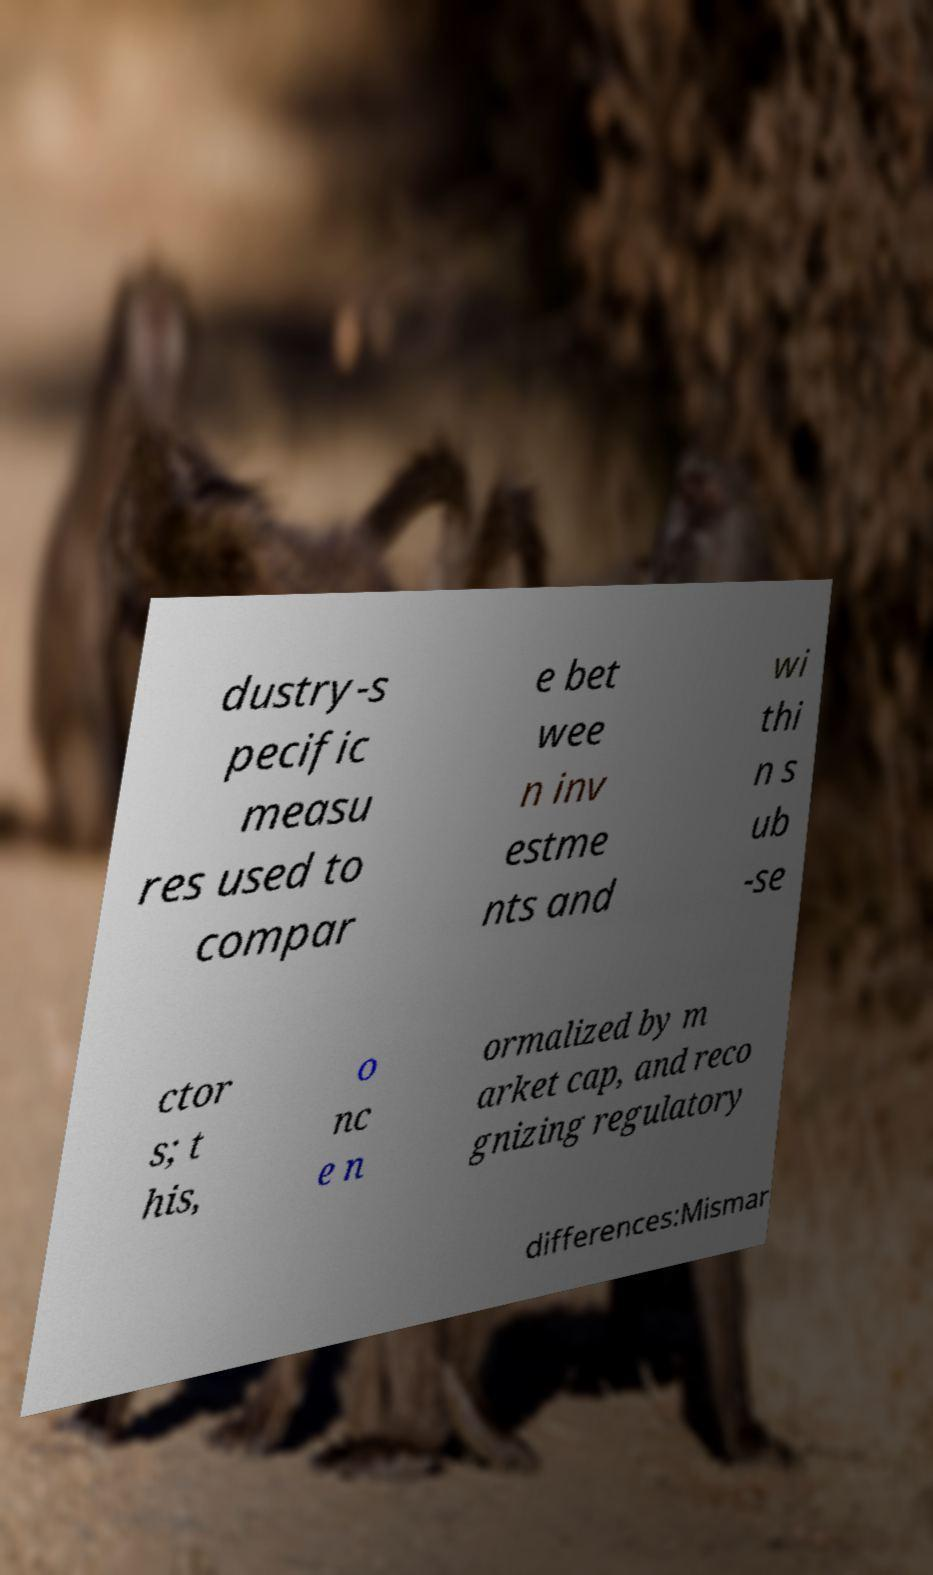Please read and relay the text visible in this image. What does it say? dustry-s pecific measu res used to compar e bet wee n inv estme nts and wi thi n s ub -se ctor s; t his, o nc e n ormalized by m arket cap, and reco gnizing regulatory differences:Mismar 